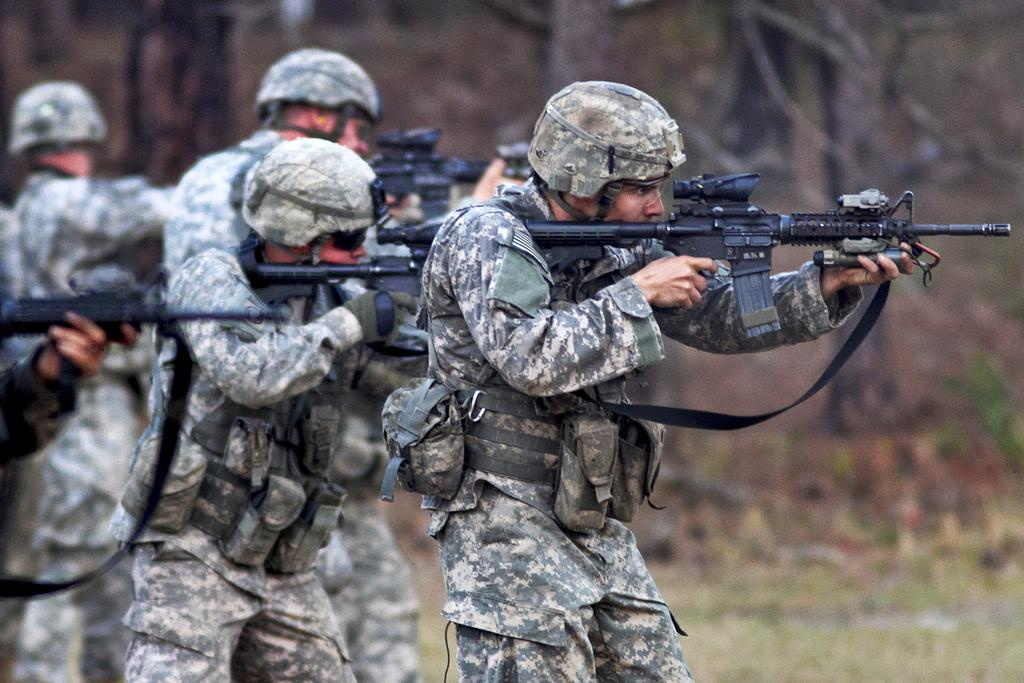Who or what is present in the image? There are people in the image. What are the people holding in their hands? The people are holding guns in their hands. Can you describe the background of the image? The background of the image is blurry. What type of branch can be seen growing out of the water in the image? There is no branch or water present in the image; it features people holding guns with a blurry background. 